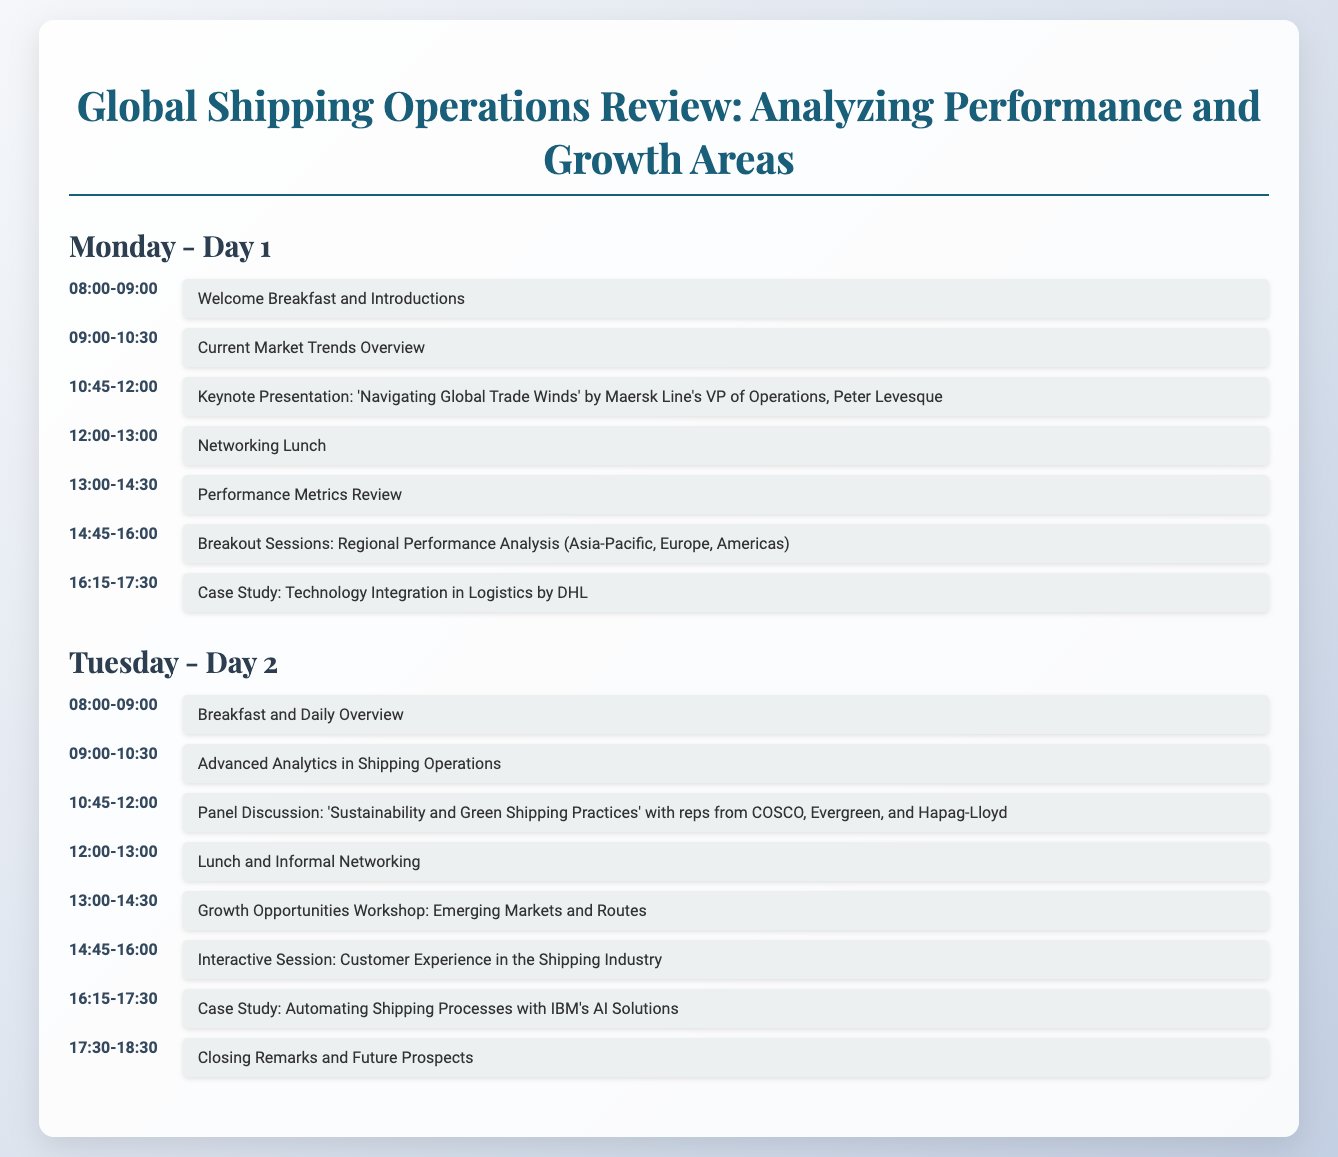What is the title of the event? The title of the event is stated in the document as "Global Shipping Operations Review: Analyzing Performance and Growth Areas."
Answer: Global Shipping Operations Review: Analyzing Performance and Growth Areas Who is the keynote speaker for Day 1? The document specifies that the keynote speaker for Day 1 is Peter Levesque.
Answer: Peter Levesque What time does the panel discussion start on Day 2? The start time for the panel discussion on Day 2 is given as 10:45 AM.
Answer: 10:45 How many breakout sessions are scheduled for Day 1? The document lists only one breakout session scheduled for Day 1.
Answer: One What is the main topic of the workshop on Day 2? The main topic of the workshop on Day 2 focuses on "Emerging Markets and Routes."
Answer: Emerging Markets and Routes What type of session occurs after lunch on Day 1? The session after lunch on Day 1 is a "Performance Metrics Review."
Answer: Performance Metrics Review How many events are listed for Tuesday? The document shows a total of six events listed for Tuesday.
Answer: Six What is a major theme of the Tuesday panel discussion? The major theme of the Tuesday panel discussion revolves around "Sustainability and Green Shipping Practices."
Answer: Sustainability and Green Shipping Practices What time is the welcome breakfast held? The document specifies that the welcome breakfast is held from 8:00 to 9:00 AM.
Answer: 08:00-09:00 